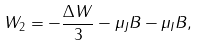<formula> <loc_0><loc_0><loc_500><loc_500>W _ { 2 } = - \frac { \Delta W } { 3 } - \mu _ { J } B - \mu _ { I } B ,</formula> 